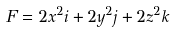Convert formula to latex. <formula><loc_0><loc_0><loc_500><loc_500>F = 2 x ^ { 2 } { i } + 2 y ^ { 2 } { j } + 2 z ^ { 2 } { k }</formula> 